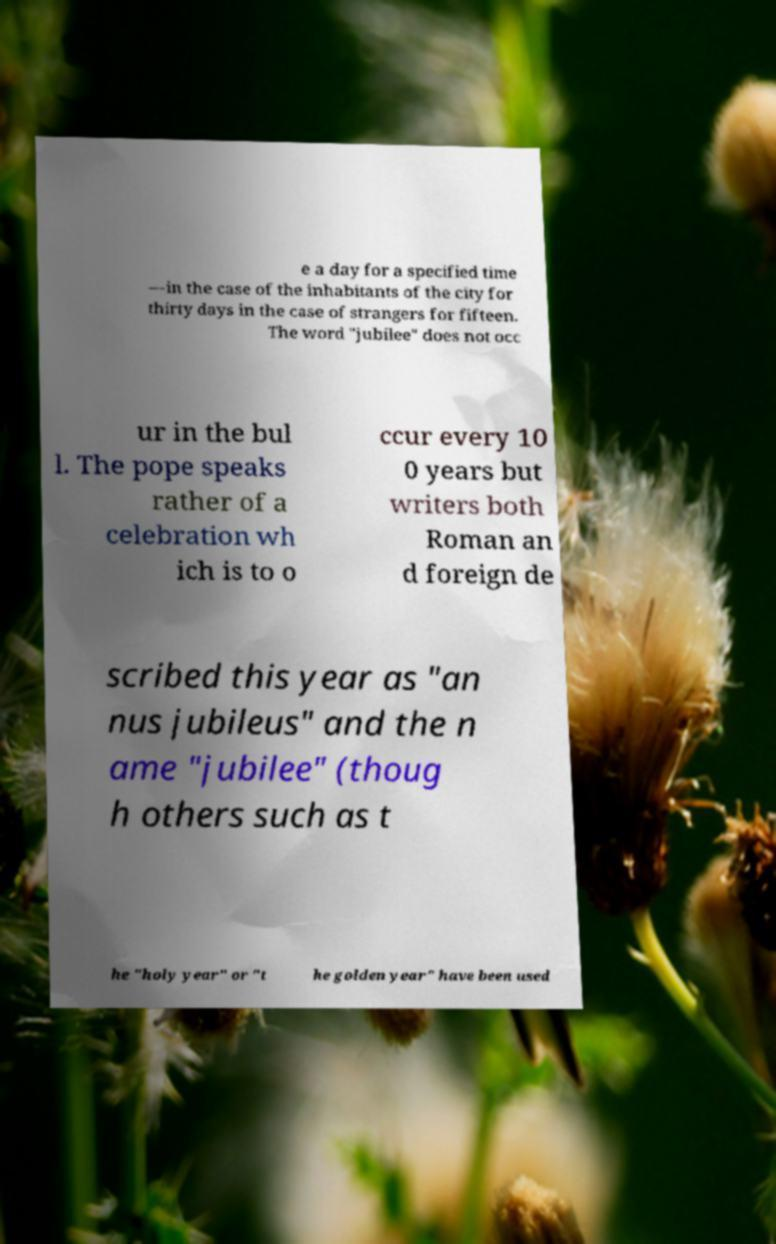I need the written content from this picture converted into text. Can you do that? e a day for a specified time —in the case of the inhabitants of the city for thirty days in the case of strangers for fifteen. The word "jubilee" does not occ ur in the bul l. The pope speaks rather of a celebration wh ich is to o ccur every 10 0 years but writers both Roman an d foreign de scribed this year as "an nus jubileus" and the n ame "jubilee" (thoug h others such as t he "holy year" or "t he golden year" have been used 